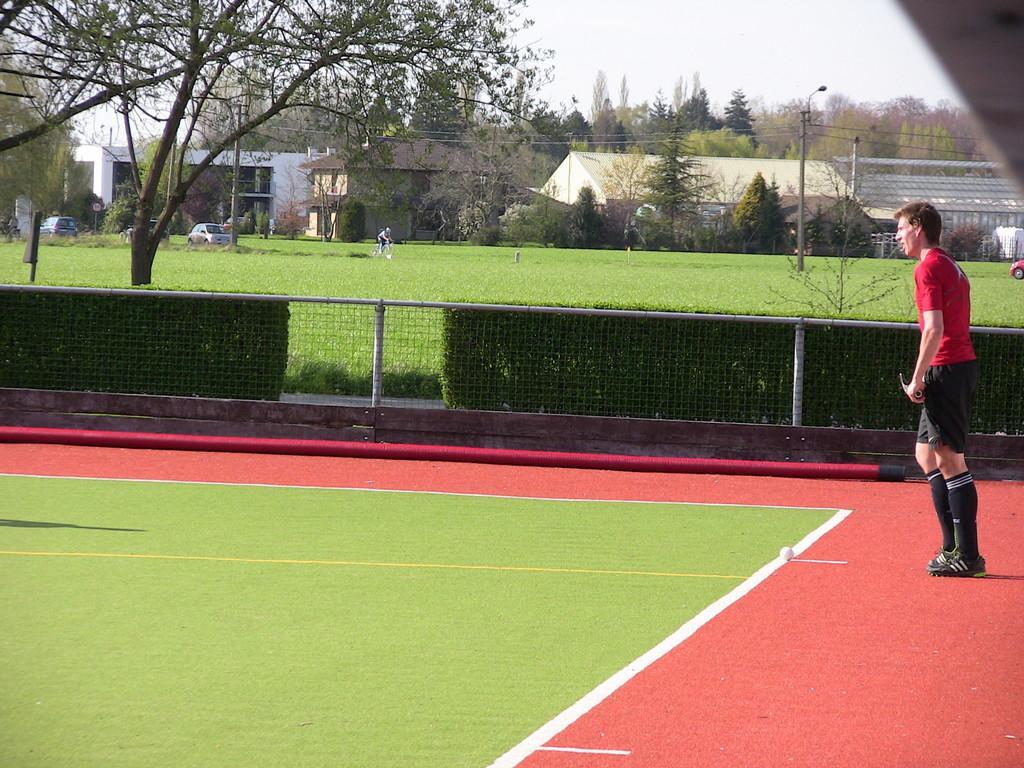Could you give a brief overview of what you see in this image? In the foreground I can see a person is standing on the ground. In the background I can see a fence, grass, trees, light poles, wires, vehicles on the road and houses. At the top I can see the sky. This image is taken during a day on the ground. 